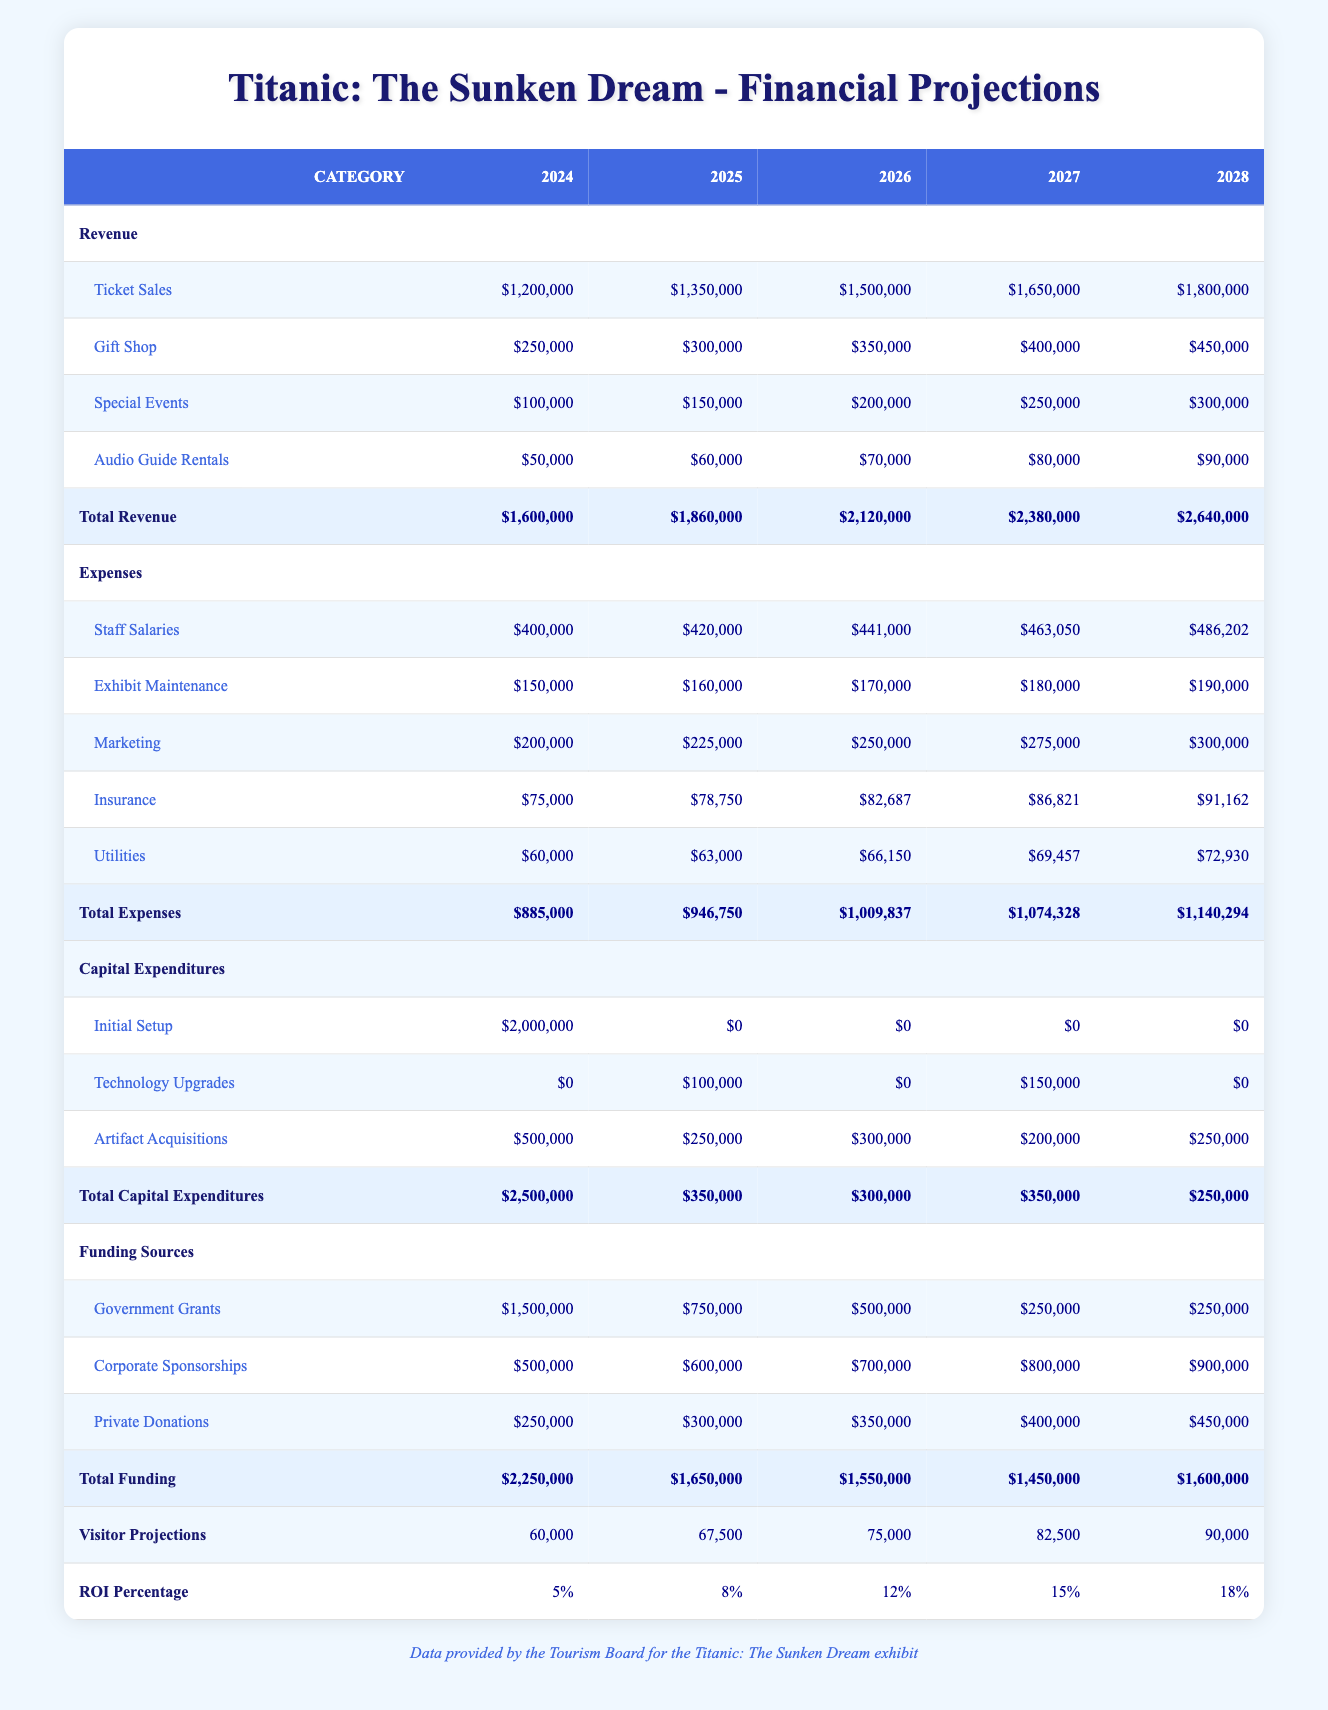What is the total revenue expected in 2025? The total revenue for 2025 can be found in the 'Total Revenue' row under the 2025 column. Referring to the table, it shows that the total revenue for 2025 is $1,860,000.
Answer: $1,860,000 What is the total amount spent on capital expenditures over the five years? To get the total capital expenditures over the five years, we look at the 'Total Capital Expenditures' row and sum the values across the years: (2,500,000 + 350,000 + 300,000 + 350,000 + 250,000) = 3,750,000.
Answer: $3,750,000 Is the revenue from ticket sales in 2026 greater than the combined revenue from special events and audio guide rentals in the same year? In 2026, ticket sales are $1,500,000. Adding special events ($200,000) and audio guide rentals ($70,000) gives $270,000. Since $1,500,000 is greater than $270,000, the statement is true.
Answer: Yes What is the year with the highest funding from government grants? Looking at the 'Government Grants' row, the funding for each year is: 2024 ($1,500,000), 2025 ($750,000), 2026 ($500,000), 2027 ($250,000), and 2028 ($250,000). The highest funding is in 2024 with $1,500,000.
Answer: 2024 What is the average staff salary expenditure over the five years? The staff salary expenditures are: $400,000, $420,000, $441,000, $463,050, and $486,202. Calculating the average: (400,000 + 420,000 + 441,000 + 463,050 + 486,202) / 5 = 422,850.40 or approximately $422,850.
Answer: $422,850 In which year is the total revenue expected to surpass $2.5 million? According to the 'Total Revenue' row, the values for each year are: $1,600,000 in 2024, $1,860,000 in 2025, $2,120,000 in 2026, $2,380,000 in 2027, and $2,640,000 in 2028. The total revenue exceeds $2.5 million starting in 2028.
Answer: 2028 What is the net profit for 2026? To calculate the net profit for 2026, we take the total revenue ($2,120,000) and subtract the total expenses ($1,009,837). Thus, net profit = $2,120,000 - $1,009,837 = $1,110,163.
Answer: $1,110,163 Is the total amount of private donations expected to increase every year? The private donations for each year are: $250,000 in 2024, $300,000 in 2025, $350,000 in 2026, $400,000 in 2027, and $450,000 in 2028. Each value is greater than the previous year, confirming a consistent increase.
Answer: Yes 